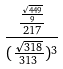<formula> <loc_0><loc_0><loc_500><loc_500>\frac { \frac { \frac { \sqrt { 4 4 9 } } { 9 } } { 2 1 7 } } { ( \frac { \sqrt { 3 1 8 } } { 3 1 3 } ) ^ { 3 } }</formula> 